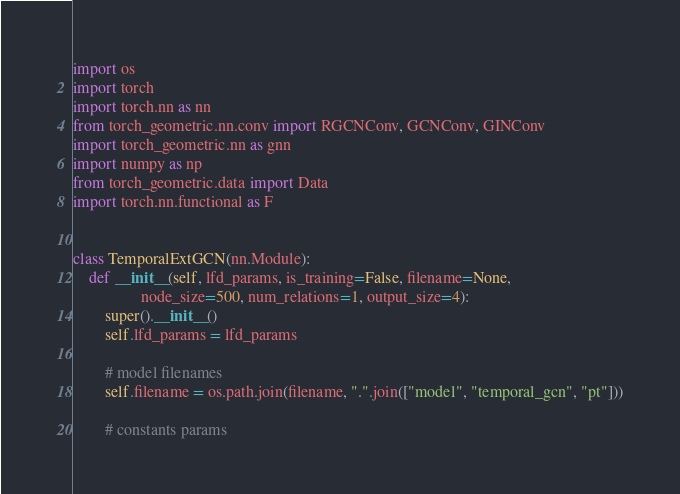<code> <loc_0><loc_0><loc_500><loc_500><_Python_>import os
import torch
import torch.nn as nn
from torch_geometric.nn.conv import RGCNConv, GCNConv, GINConv
import torch_geometric.nn as gnn
import numpy as np
from torch_geometric.data import Data
import torch.nn.functional as F


class TemporalExtGCN(nn.Module):
    def __init__(self, lfd_params, is_training=False, filename=None,
                 node_size=500, num_relations=1, output_size=4):
        super().__init__()
        self.lfd_params = lfd_params

        # model filenames
        self.filename = os.path.join(filename, ".".join(["model", "temporal_gcn", "pt"]))

        # constants params</code> 